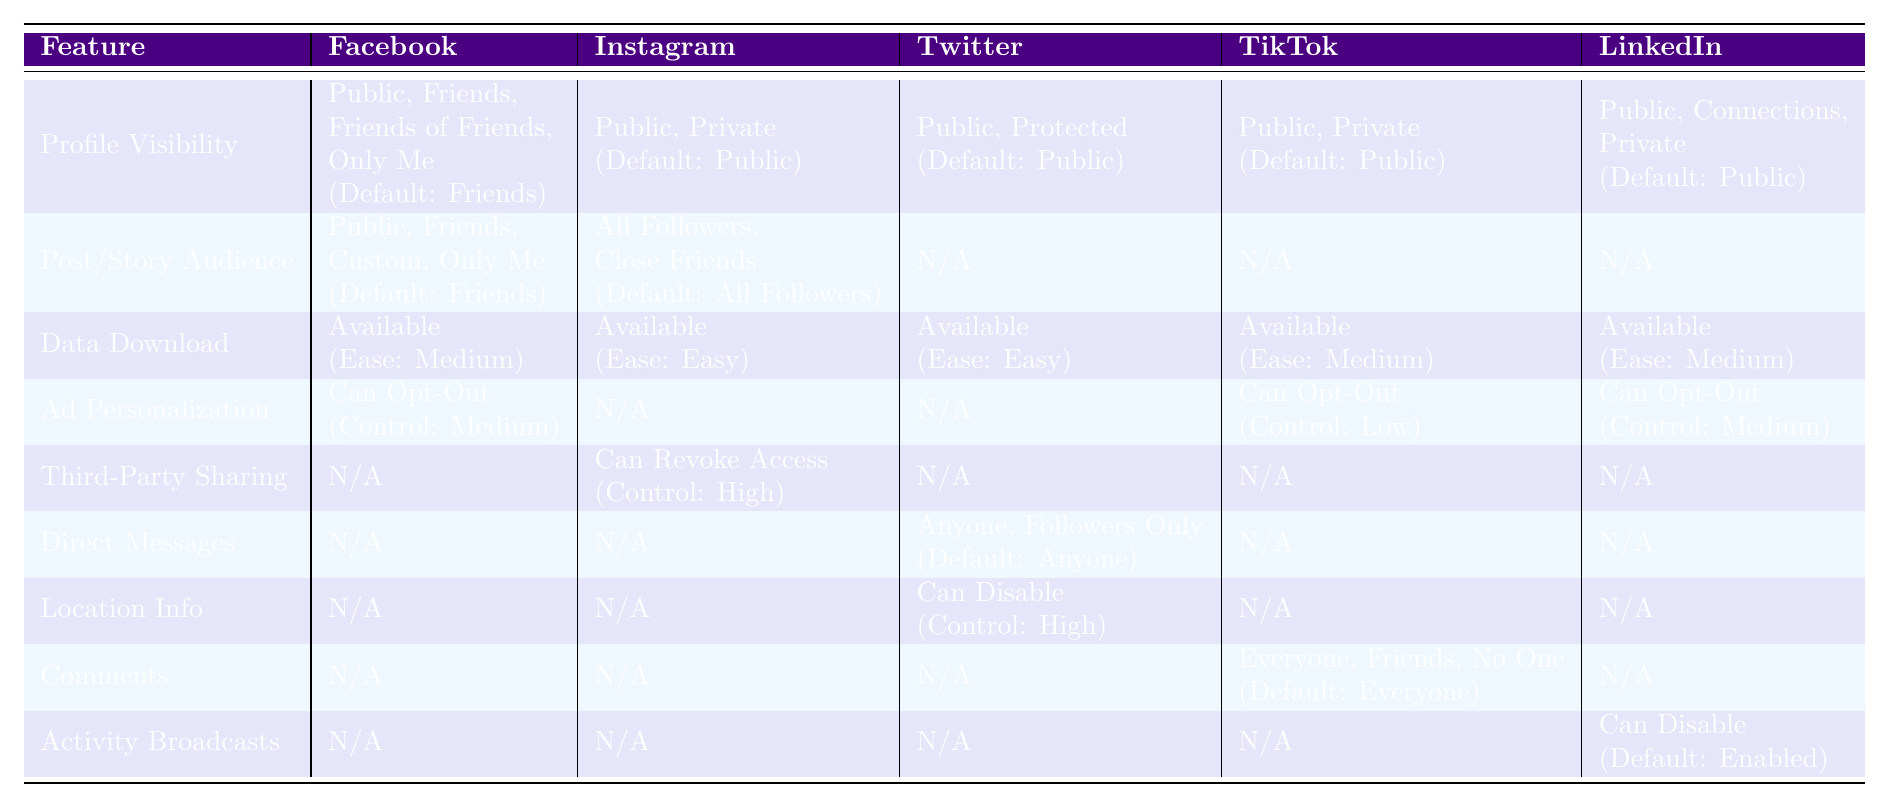What are the default privacy settings for Instagram account privacy? The default privacy setting for Instagram account privacy is "Public," as indicated in the table under the section for Instagram.
Answer: Public Which platform has the easiest access to data download? According to the table, both Instagram and Twitter have easy access for data downloads. However, Instagram is specified explicitly as "Ease: Easy," making it a correct response for the easiest access.
Answer: Instagram Can you opt-out of ad personalization on TikTok? The table shows that TikTok allows opting out of personalized ads but specifies its granular control as low. Thus, you can opt-out.
Answer: Yes Which social media platform has the highest level of granular control for third-party app sharing? The table indicates that Instagram has high granular control for third-party app sharing, while others don't provide this feature. Thus, Instagram is the answer.
Answer: Instagram Is there a way to control the audience for posts on Twitter? The table specifies that Twitter does not have audience control for posts as Twitter's feature for audience control is only applicable to tweet privacy. Therefore, there is no audience control for posts in Twitter.
Answer: No What is the default setting for comments on TikTok? The default setting for comments on TikTok is "Everyone," according to the table which outlines TikTok's comments feature.
Answer: Everyone How does the granular control for ad personalization on Facebook compare to LinkedIn? The table indicates that Facebook has medium granular control for ad personalization while LinkedIn also offers medium control. Therefore, both Facebook and LinkedIn have the same level of granular control for this feature.
Answer: Equal (Medium) Which platforms allow users to download their data? The table confirms that all platforms—Facebook, Instagram, Twitter, TikTok, and LinkedIn—allow users to download their data.
Answer: All platforms Among the listed features, which platform offers the ability to revoke access for third-party app sharing? The table indicates that only Instagram allows users to revoke access for third-party app sharing, making it the unique platform for this feature.
Answer: Instagram What is the difference in ease of access for data download between Instagram and Facebook? The table states that Instagram has an "Easy" ease of access for data download compared to Facebook, which has "Medium." Therefore, the difference is that Instagram is easier than Facebook.
Answer: Instagram is easier than Facebook 